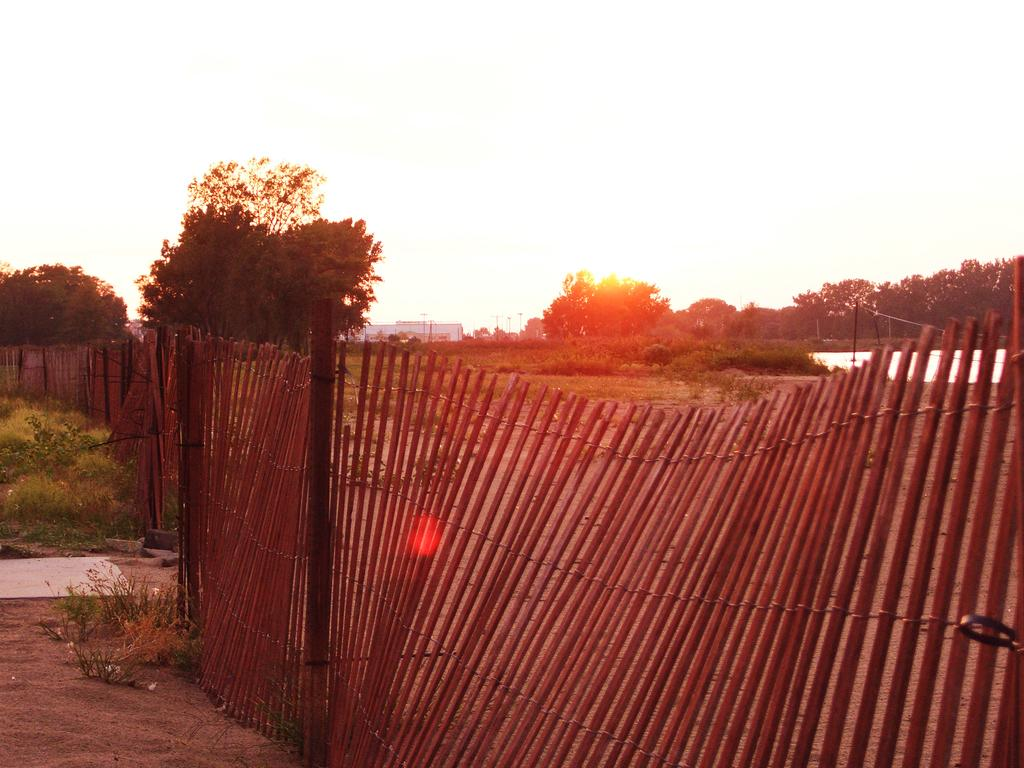What type of boundary can be seen in the foreground of the image? There is a wooden bamboo boundary in the foreground of the image. What other structures are visible in the image? Poles and a building structure can be seen in the image. What type of vegetation is present in the image? Trees and grassland are visible in the image. What can be seen in the background of the image? The sky and a building structure are visible in the background of the image. How many boys are playing soccer in the image? There are no boys or soccer game present in the image. What expertise does the night sky have in the image? The image does not depict a night sky, and therefore there is no expertise to discuss. 